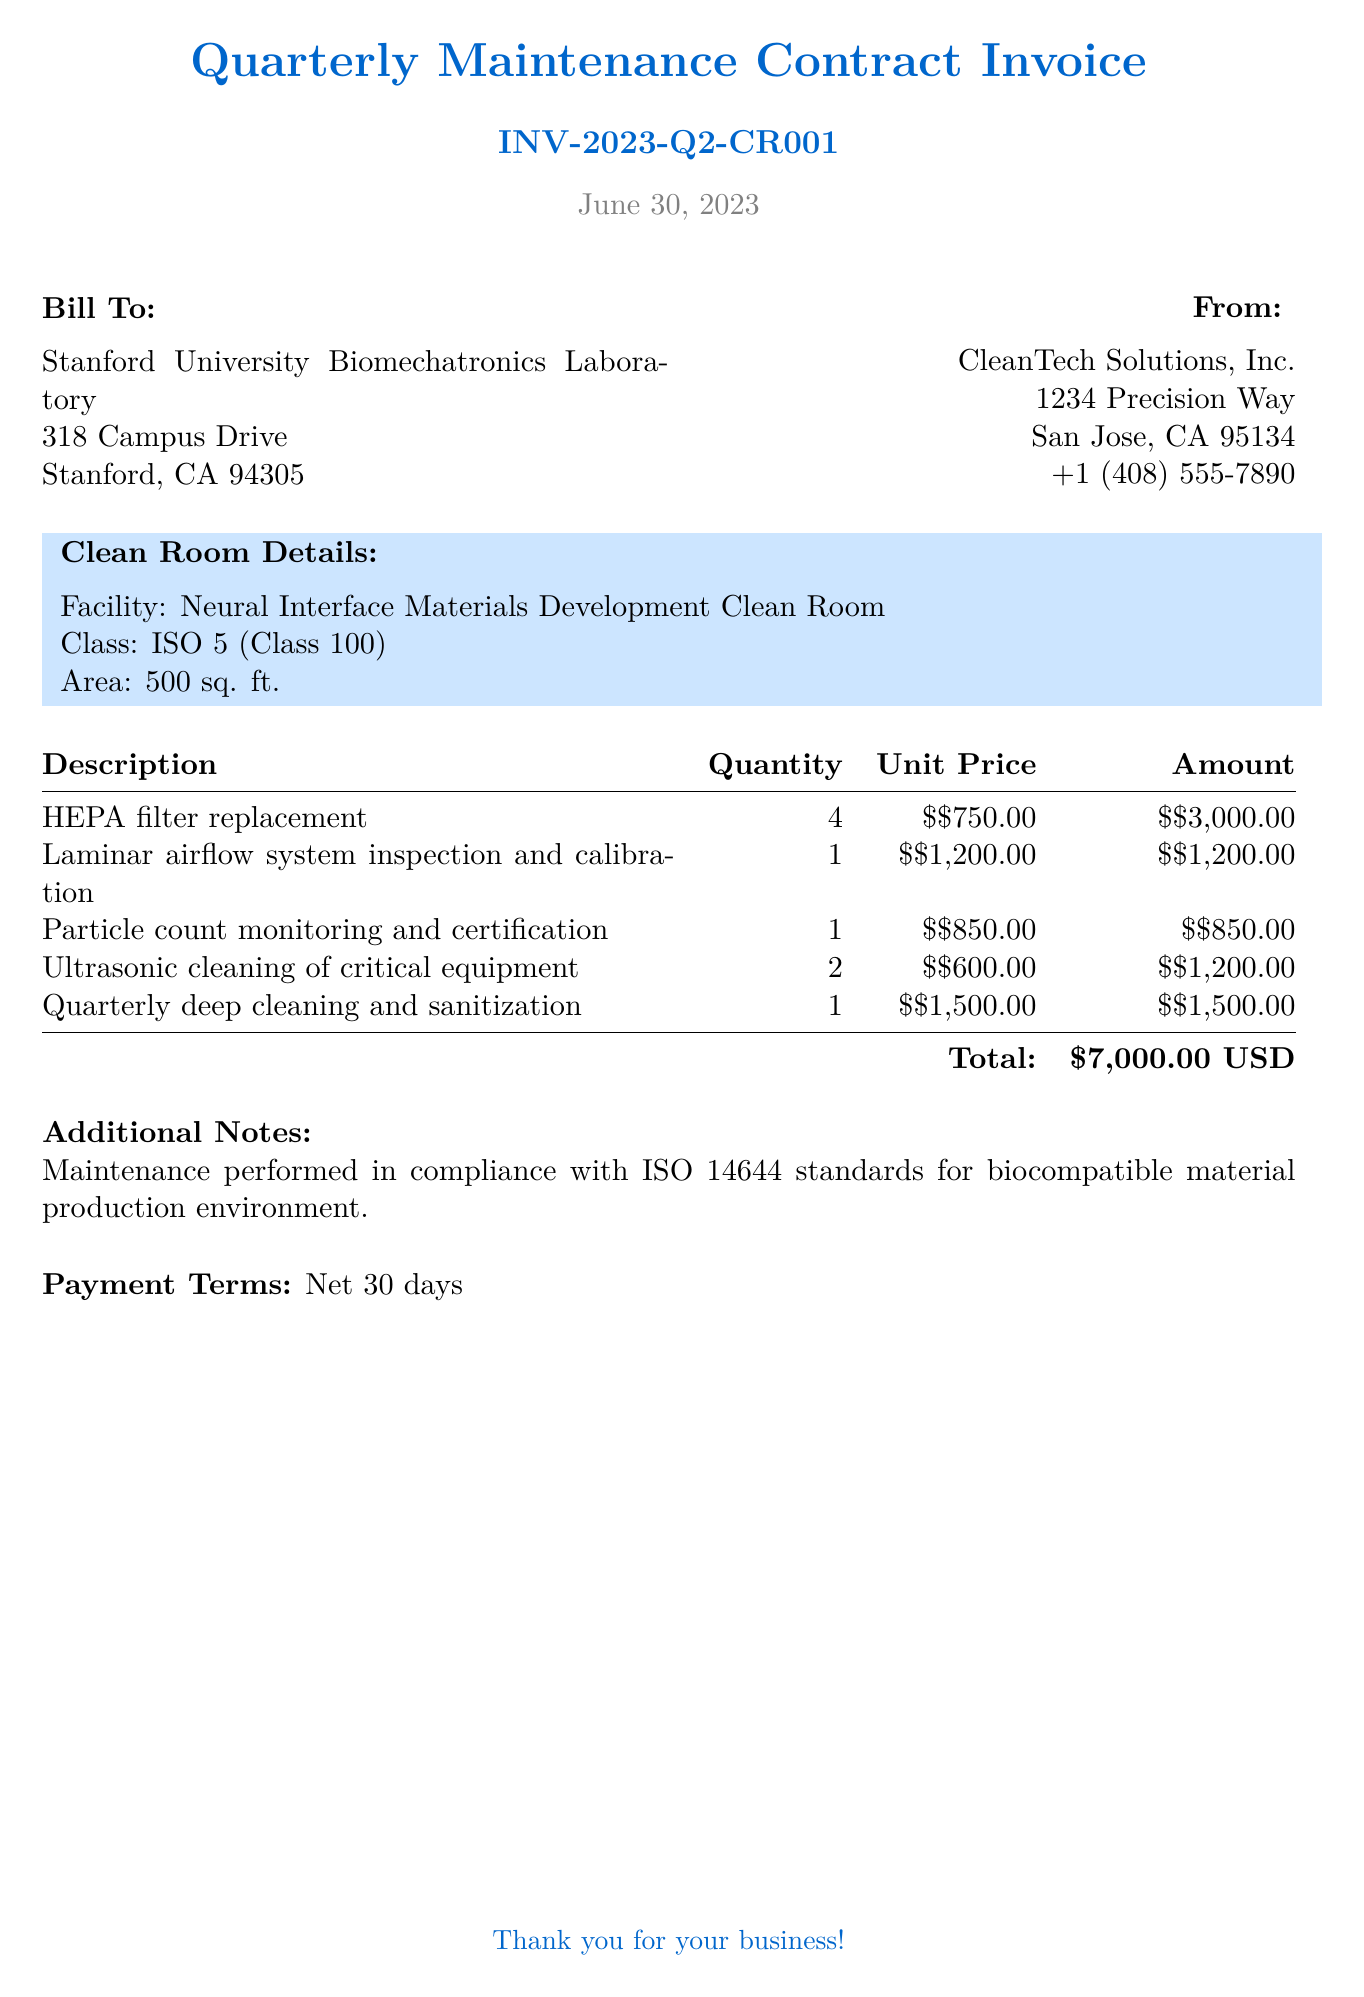What is the invoice number? The invoice number is stated prominently at the top of the document for identification purposes.
Answer: INV-2023-Q2-CR001 What is the total amount due? The total amount due is calculated from the sum of all listed services in the invoice.
Answer: $7,000.00 USD Who is the billing recipient? The billing recipient is specified in the "Bill To" section of the invoice.
Answer: Stanford University Biomechatronics Laboratory How many HEPA filters are replaced? The quantity of HEPA filter replacements is included in the description section of the invoice.
Answer: 4 What is the term for payment? The payment term is detailed near the bottom of the invoice, indicating when payment is expected.
Answer: Net 30 days What class is the clean room? The clean room class information can be found in the clean room details section of the document.
Answer: ISO 5 (Class 100) How many services involve cleaning? The services that are related to cleaning can be counted from the description provided.
Answer: 3 What is the area of the clean room? The area of the clean room is mentioned under the clean room details.
Answer: 500 sq. ft 